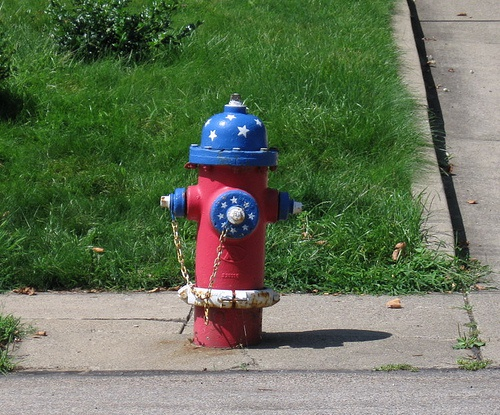Describe the objects in this image and their specific colors. I can see a fire hydrant in darkgreen, maroon, black, salmon, and navy tones in this image. 